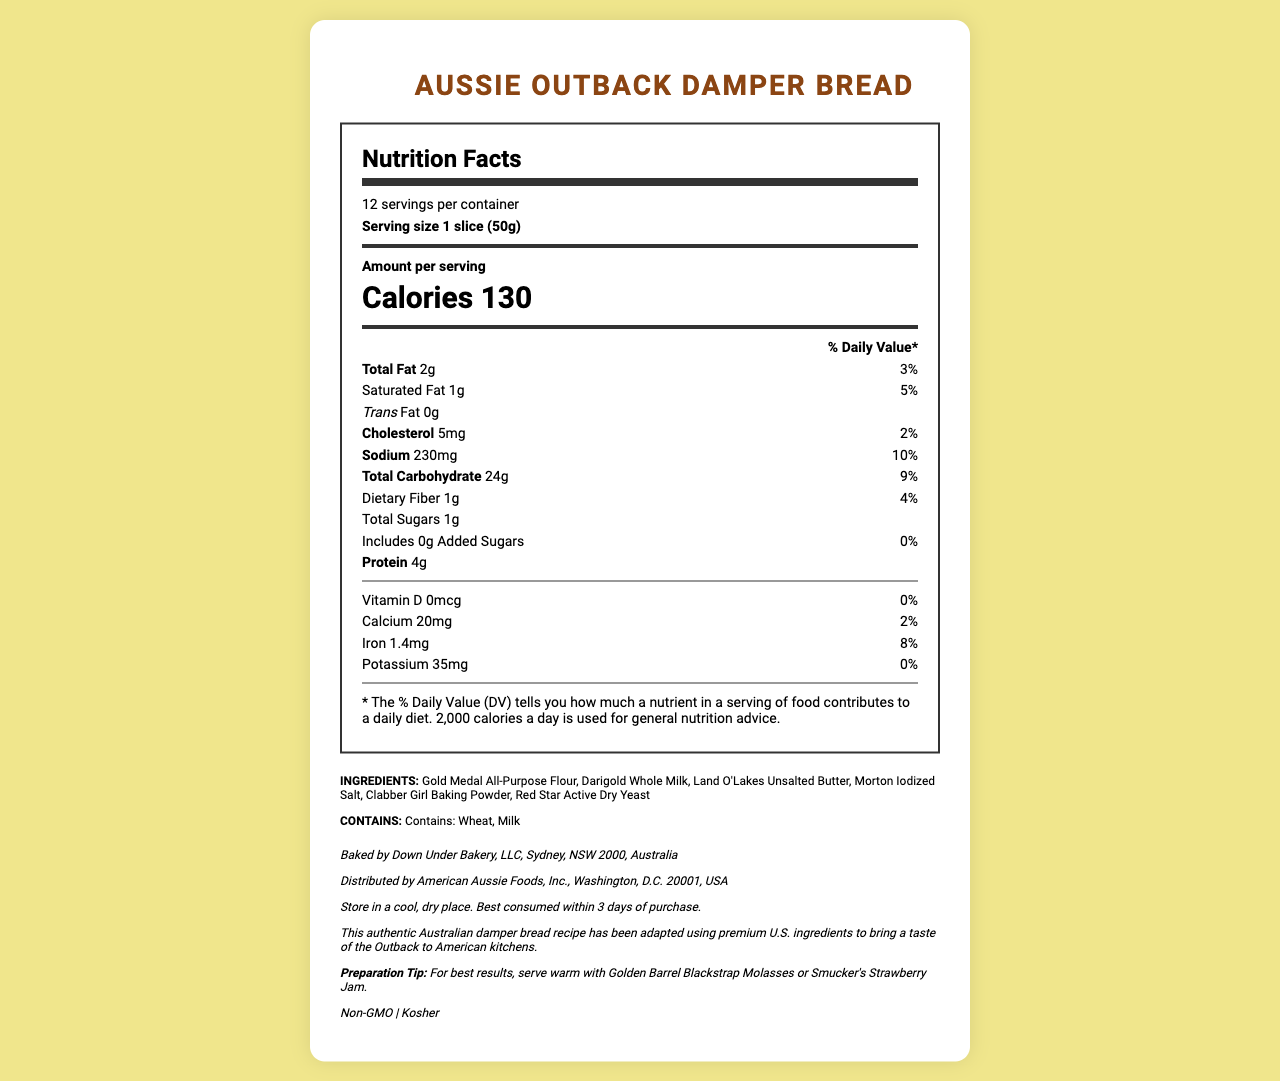How many servings are in a container of Aussie Outback Damper Bread? The label indicates that there are 12 servings per container.
Answer: 12 How many calories are in one slice (50g) serving of the bread? The Nutrition Facts label lists 130 calories per serving.
Answer: 130 What is the total amount of fat in one serving? The label shows that there are 2 grams of total fat per serving.
Answer: 2g What percentage of the daily value for sodium does one serving provide? The label indicates that one serving contains 230mg of sodium, which is 10% of the daily value.
Answer: 10% How many grams of protein are in one serving? The Nutrition Facts label shows there are 4 grams of protein per serving.
Answer: 4g Which of the following ingredients are present in the bread? A. Nuts B. Almond flour C. Wheat The allergen statement shows that the bread contains wheat but does not specify nuts or almond flour as ingredients.
Answer: C What is the amount of dietary fiber in one serving? A. 0g B. 1g C. 2g D. 3g The label indicates that there is 1 gram of dietary fiber per serving.
Answer: B Is the bread USDA Organic? The document specifies that the bread is not USDA Organic.
Answer: No Can this bread be classified as Kosher? The document states that the bread is Kosher.
Answer: Yes Summarize the nutritional information and key details about this bread. This summary captures the nutritional information and essential details provided by the document, highlighting the key components and placement information.
Answer: The Aussie Outback Damper Bread has 12 servings per container, with each serving (1 slice, 50g) containing 130 calories, 2g of total fat, 1g of saturated fat, 230mg of sodium, 24g of carbohydrates, 1g of dietary fiber, 1g of total sugars, with 0g added sugars, and 4g of protein. It includes ingredients like Gold Medal All-Purpose Flour and Land O'Lakes Unsalted Butter. It contains wheat and milk, is non-GMO, Kosher, but not USDA Organic. Made by Down Under Bakery, LLC, it should be stored in a cool, dry place and is best consumed within 3 days of purchase. What is the expiration duration for the bread after purchase? The storage instructions advise consuming the bread within 3 days of purchase.
Answer: 3 days What vitamin listed has a daily value percentage of zero? The Nutrition Facts label lists 0mcg of Vitamin D, corresponding to a 0% daily value.
Answer: Vitamin D What allergenic ingredients are contained in the damper bread? The allergen statement explicitly mentions wheat and milk as allergenic ingredients.
Answer: Wheat, Milk Is the preparation tip related to any specific condiments? The preparation tip suggests serving the bread with Golden Barrel Blackstrap Molasses or Smucker's Strawberry Jam.
Answer: Yes Where is the bread manufactured? The manufacturer info states that the bread is baked by Down Under Bakery, LLC in Sydney, NSW 2000, Australia.
Answer: Sydney, NSW 2000, Australia What is the calcium content per serving of this bread? The Nutrition Facts label lists 20mg of calcium per serving.
Answer: 20mg Does the bread include any trans fat? The label indicates 0 grams of trans fat per serving.
Answer: No Can you identify the distributor of the bread? The distributor information is not directly asking for any of the visible specific details from the Nutrition Facts Label.
Answer: I don't know 